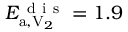Convert formula to latex. <formula><loc_0><loc_0><loc_500><loc_500>E _ { a , V _ { 2 } } ^ { d i s } = 1 . 9</formula> 